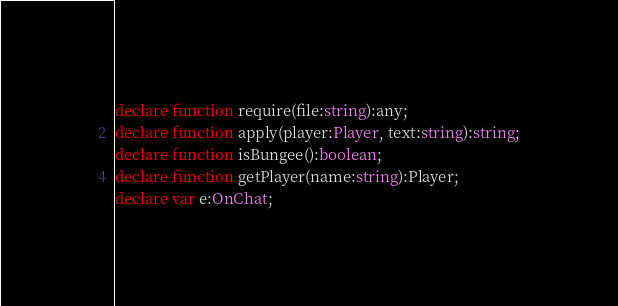<code> <loc_0><loc_0><loc_500><loc_500><_TypeScript_>declare function require(file:string):any;
declare function apply(player:Player, text:string):string;
declare function isBungee():boolean;
declare function getPlayer(name:string):Player;
declare var e:OnChat;</code> 